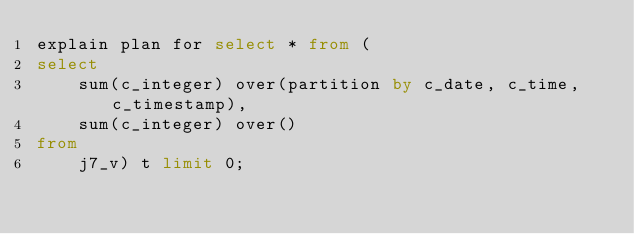Convert code to text. <code><loc_0><loc_0><loc_500><loc_500><_SQL_>explain plan for select * from (
select 
	sum(c_integer) over(partition by c_date, c_time, c_timestamp),
	sum(c_integer) over()
from
	j7_v) t limit 0;
</code> 